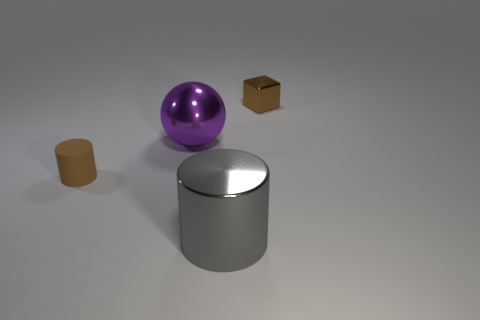What materials do the objects in the image appear to be made of? The sphere has a reflective surface suggesting it may be made of a polished metal or plastic. The cube has a matte finish, possibly resembling cardboard. The cylinder appears metallic due to its reflective surface, and the small matte cylinder could be made of a material like unpolished stone or clay. 